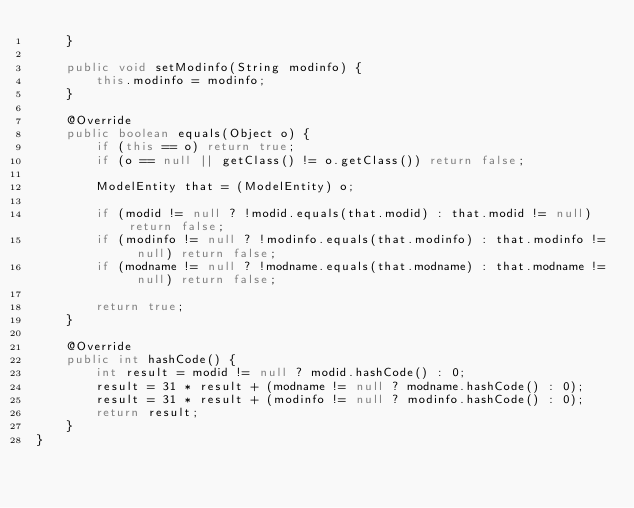Convert code to text. <code><loc_0><loc_0><loc_500><loc_500><_Java_>    }

    public void setModinfo(String modinfo) {
        this.modinfo = modinfo;
    }

    @Override
    public boolean equals(Object o) {
        if (this == o) return true;
        if (o == null || getClass() != o.getClass()) return false;

        ModelEntity that = (ModelEntity) o;

        if (modid != null ? !modid.equals(that.modid) : that.modid != null) return false;
        if (modinfo != null ? !modinfo.equals(that.modinfo) : that.modinfo != null) return false;
        if (modname != null ? !modname.equals(that.modname) : that.modname != null) return false;

        return true;
    }

    @Override
    public int hashCode() {
        int result = modid != null ? modid.hashCode() : 0;
        result = 31 * result + (modname != null ? modname.hashCode() : 0);
        result = 31 * result + (modinfo != null ? modinfo.hashCode() : 0);
        return result;
    }
}
</code> 